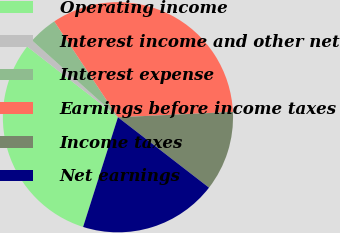Convert chart to OTSL. <chart><loc_0><loc_0><loc_500><loc_500><pie_chart><fcel>Operating income<fcel>Interest income and other net<fcel>Interest expense<fcel>Earnings before income taxes<fcel>Income taxes<fcel>Net earnings<nl><fcel>30.63%<fcel>1.09%<fcel>4.05%<fcel>33.59%<fcel>11.21%<fcel>19.42%<nl></chart> 